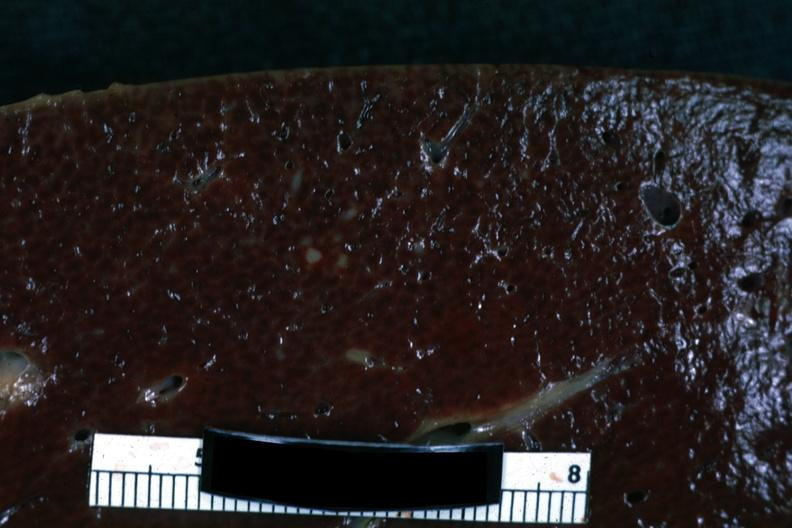s feet present?
Answer the question using a single word or phrase. No 